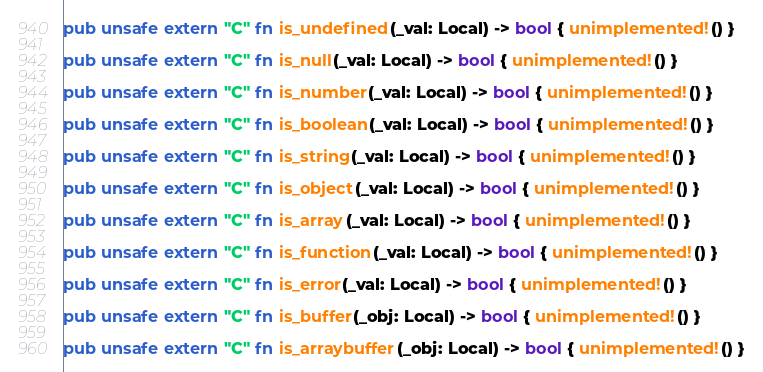Convert code to text. <code><loc_0><loc_0><loc_500><loc_500><_Rust_>pub unsafe extern "C" fn is_undefined(_val: Local) -> bool { unimplemented!() }

pub unsafe extern "C" fn is_null(_val: Local) -> bool { unimplemented!() }

pub unsafe extern "C" fn is_number(_val: Local) -> bool { unimplemented!() }

pub unsafe extern "C" fn is_boolean(_val: Local) -> bool { unimplemented!() }

pub unsafe extern "C" fn is_string(_val: Local) -> bool { unimplemented!() }

pub unsafe extern "C" fn is_object(_val: Local) -> bool { unimplemented!() }

pub unsafe extern "C" fn is_array(_val: Local) -> bool { unimplemented!() }

pub unsafe extern "C" fn is_function(_val: Local) -> bool { unimplemented!() }

pub unsafe extern "C" fn is_error(_val: Local) -> bool { unimplemented!() }

pub unsafe extern "C" fn is_buffer(_obj: Local) -> bool { unimplemented!() }

pub unsafe extern "C" fn is_arraybuffer(_obj: Local) -> bool { unimplemented!() }
</code> 